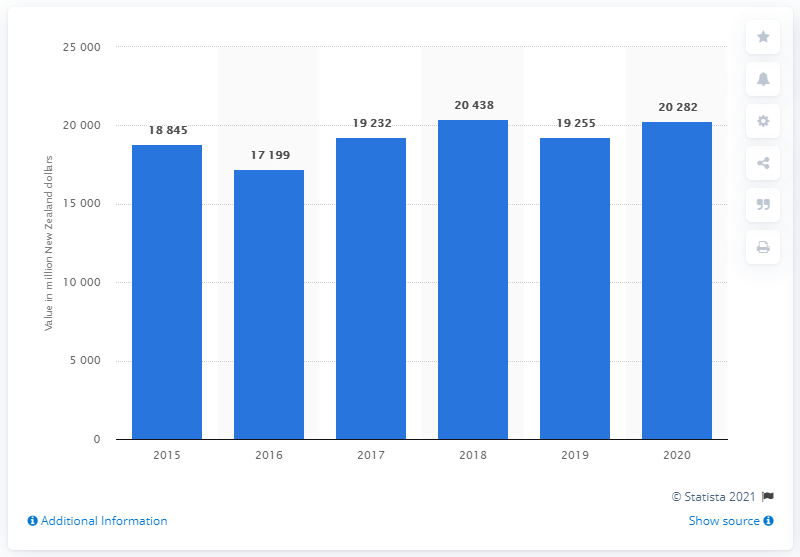List a handful of essential elements in this visual. Fonterra's sales revenue in New Zealand dollars in 2020 was 202,821. In 2015, the sales revenue of Fonterra in New Zealand dollars was approximately 18,845. 